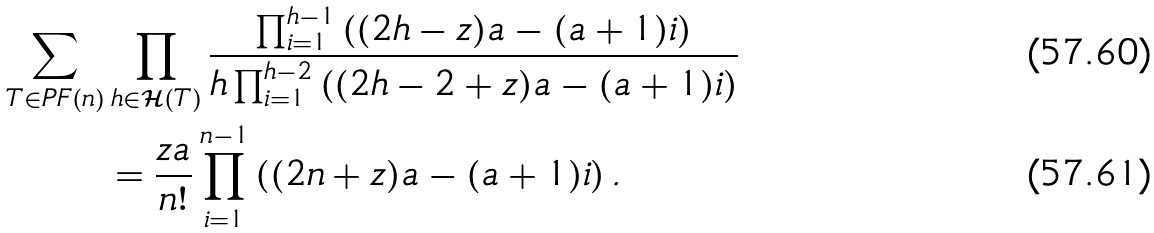Convert formula to latex. <formula><loc_0><loc_0><loc_500><loc_500>\sum _ { T \in P F ( n ) } & \prod _ { h \in \mathcal { H } ( T ) } \frac { \prod _ { i = 1 } ^ { h - 1 } \left ( ( 2 h - z ) a - ( a + 1 ) i \right ) } { h \prod _ { i = 1 } ^ { h - 2 } \left ( ( 2 h - 2 + z ) a - ( a + 1 ) i \right ) } \\ & = \frac { z a } { n ! } \prod _ { i = 1 } ^ { n - 1 } \left ( ( 2 n + z ) a - ( a + 1 ) i \right ) .</formula> 